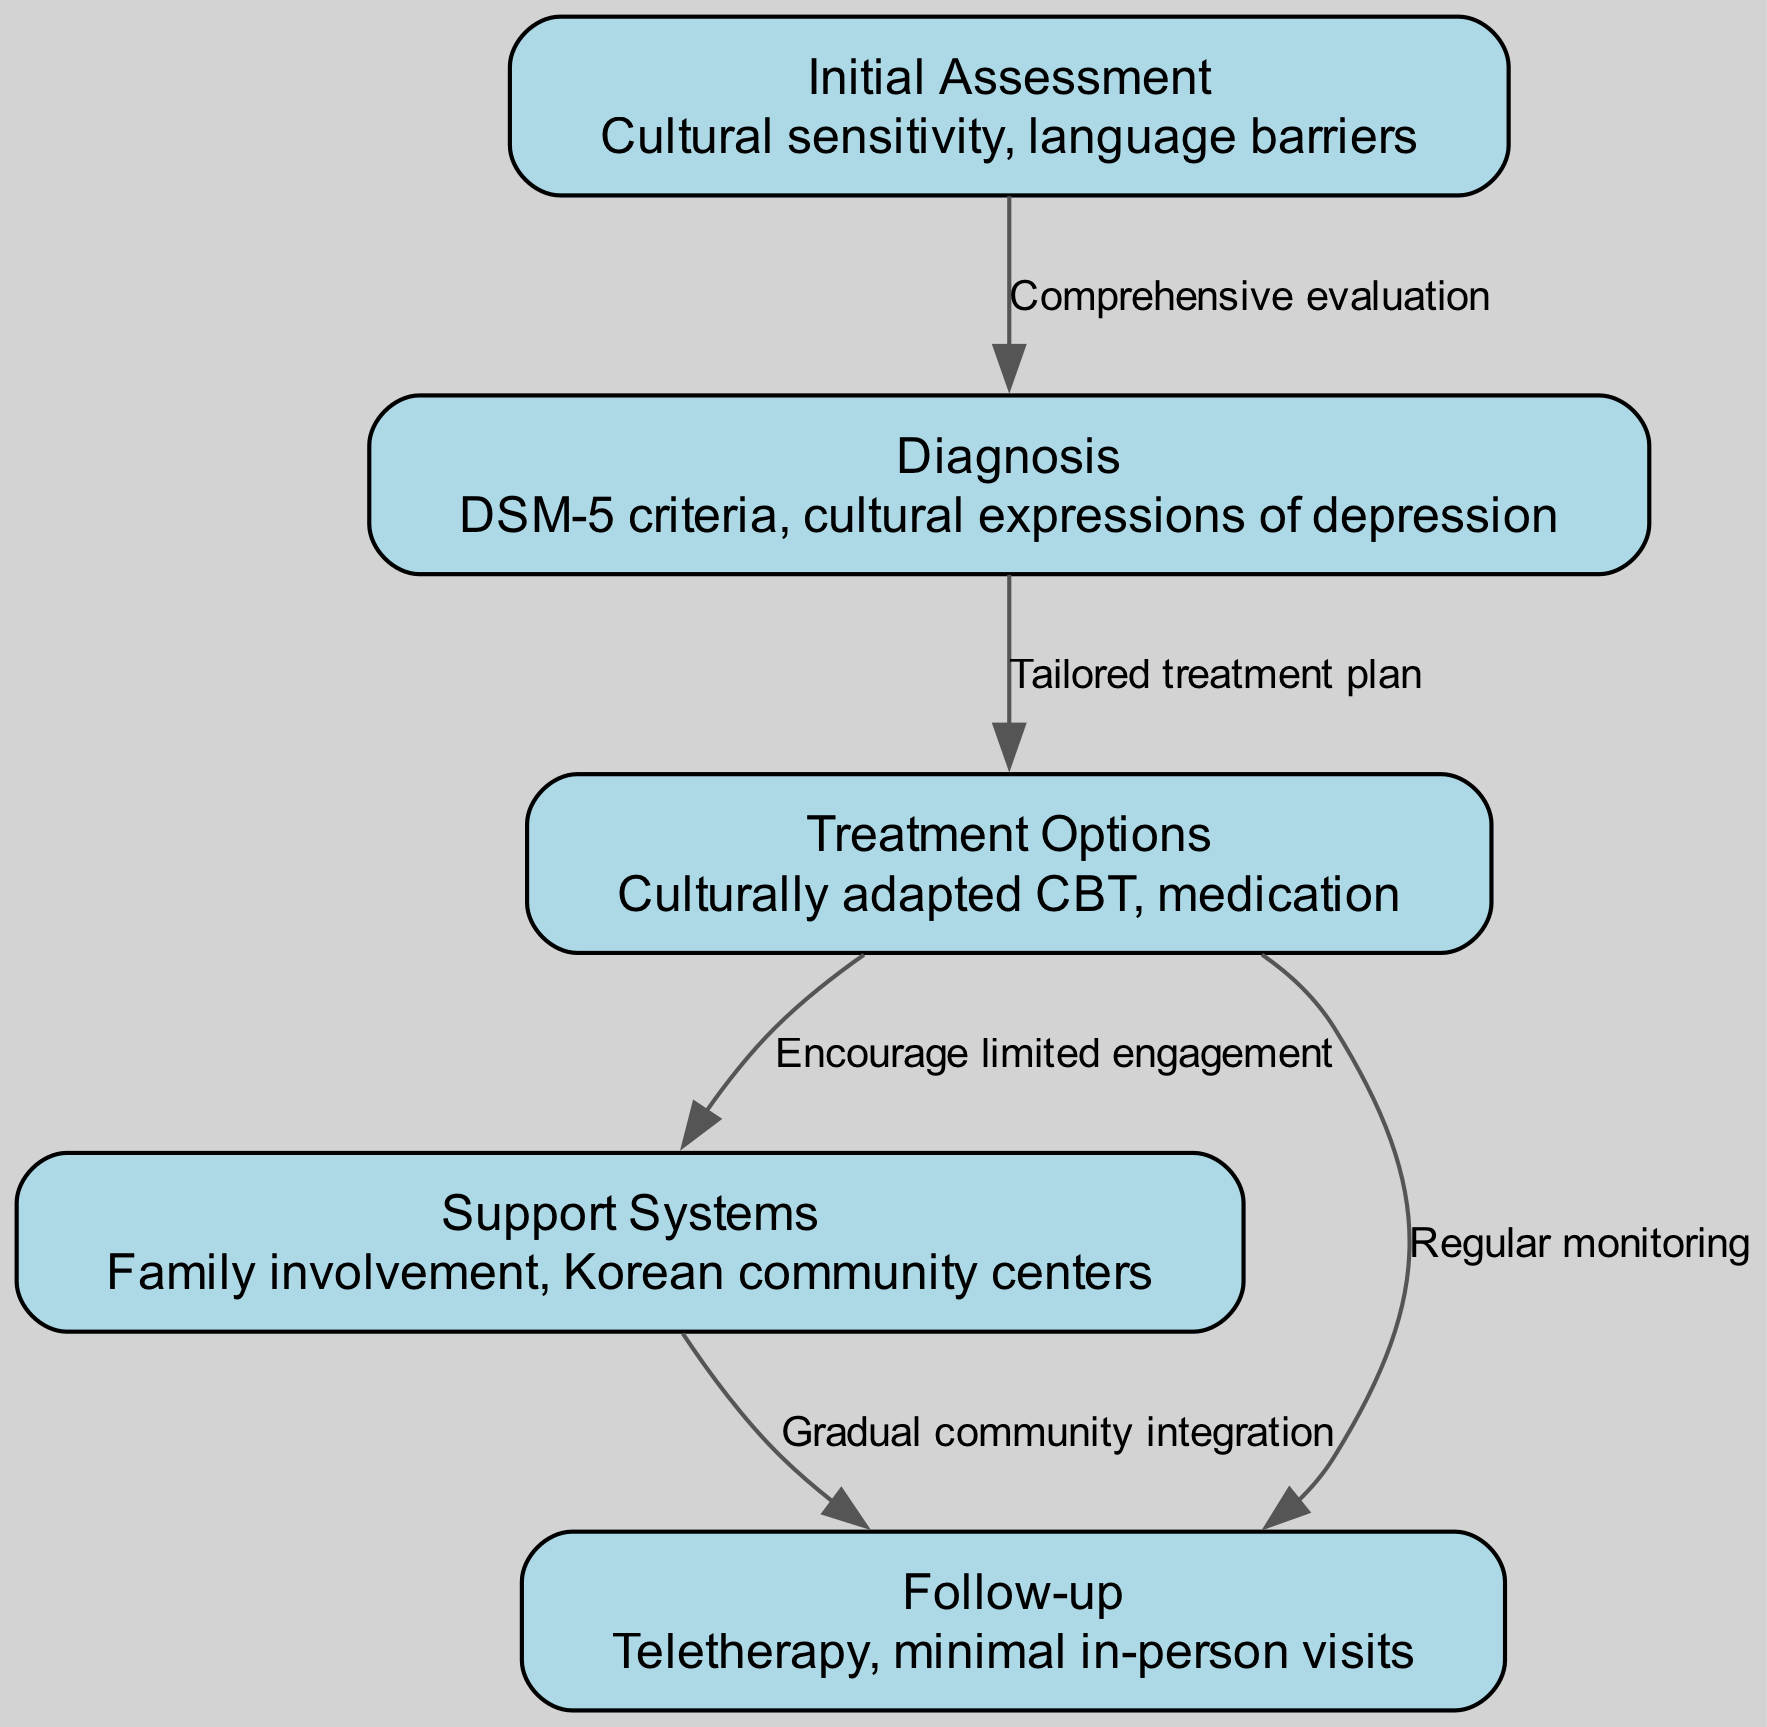What is the first step in the clinical pathway? The first node in the diagram is "Initial Assessment," which outlines the starting point for managing depression. This step involves understanding cultural sensitivity and addressing language barriers in the process.
Answer: Initial Assessment How many nodes are present in the diagram? By counting the listed nodes in the provided data, there are five distinct stages depicted in the clinical pathway: Initial Assessment, Diagnosis, Treatment Options, Support Systems, and Follow-up.
Answer: 5 What does the edge from "Diagnosis" to "Treatment Options" represent? The edge indicates the transition from the diagnosis phase to determining treatment options, emphasizing the need for a tailored treatment plan based on the diagnosis made in the previous step.
Answer: Tailored treatment plan What type of therapy is suggested for follow-up? According to the diagram, follow-up involves teletherapy as one of the methods for managing depression, highlighting the preference for minimal in-person visits during this stage.
Answer: Teletherapy How are support systems integrated into the treatment plan? The pathway indicates that support systems, such as family involvement and Korean community centers, are encouraged after the treatment options, allowing for limited engagement to aid recovery.
Answer: Encourage limited engagement What is the relationship between "Support Systems" and "Follow-up"? The diagram shows that there is a flow from Support Systems to Follow-up, indicating that as community integration occurs, there will be a gradual transition into follow-up activities that assist in managing depression.
Answer: Gradual community integration What is assessed during the "Initial Assessment" stage? In the Initial Assessment stage, cultural sensitivity and language barriers are specifically highlighted as critical factors that need to be evaluated to ensure proper management of depression in Korean American immigrants.
Answer: Cultural sensitivity, language barriers What criteria are used for "Diagnosis"? The diagnosis stage utilizes the DSM-5 criteria while also considering the cultural expressions of depression, ensuring that cultural nuances are recognized during the diagnostic process.
Answer: DSM-5 criteria, cultural expressions of depression 